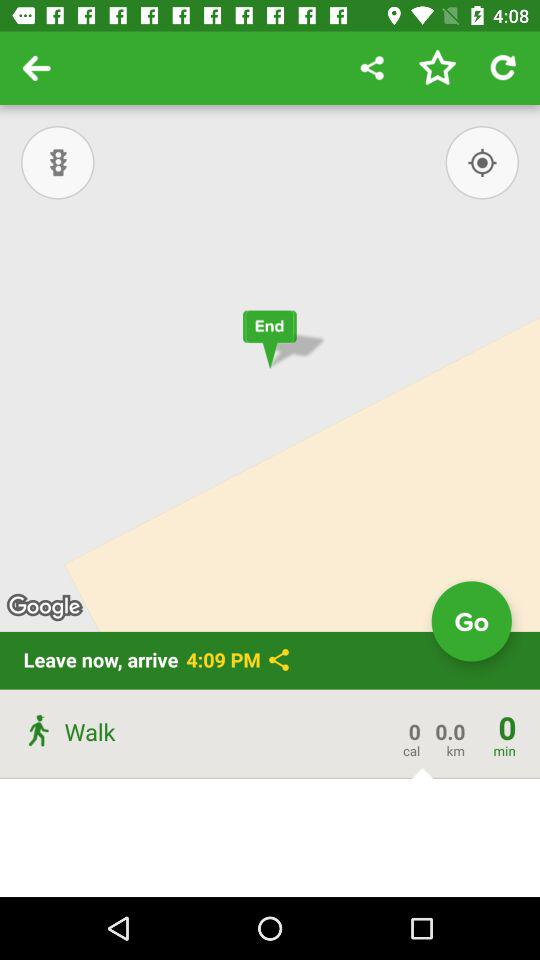What was the duration of the walk? The duration of the walk was 0 minutes. 